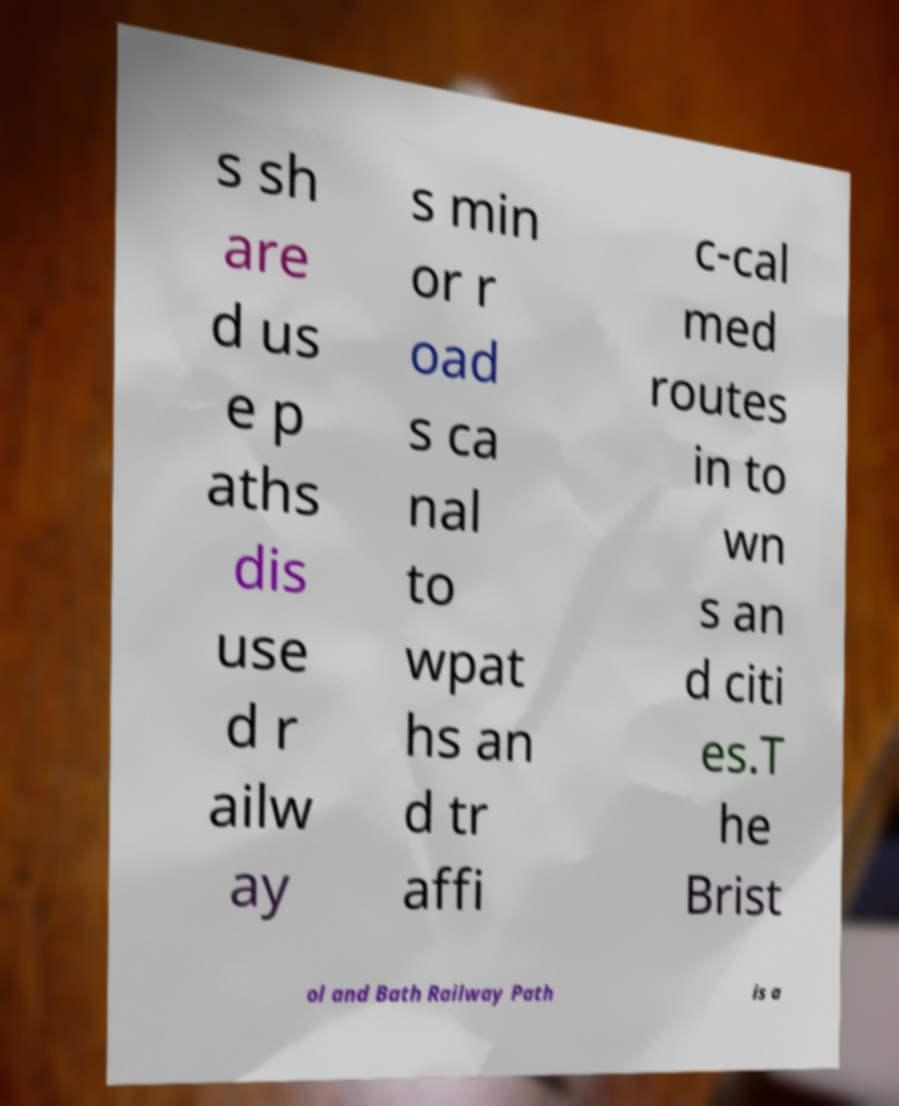I need the written content from this picture converted into text. Can you do that? s sh are d us e p aths dis use d r ailw ay s min or r oad s ca nal to wpat hs an d tr affi c-cal med routes in to wn s an d citi es.T he Brist ol and Bath Railway Path is a 